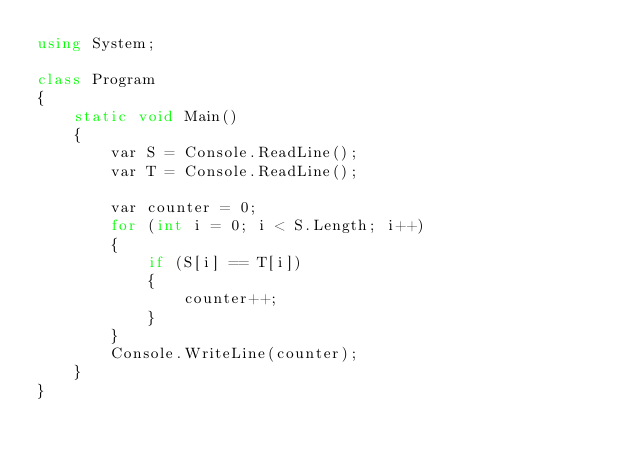<code> <loc_0><loc_0><loc_500><loc_500><_C#_>using System;

class Program
{
    static void Main()
    {
        var S = Console.ReadLine();
        var T = Console.ReadLine();

        var counter = 0;
        for (int i = 0; i < S.Length; i++)
        {
            if (S[i] == T[i])
            {
                counter++;
            }
        }
        Console.WriteLine(counter);
    }
}
</code> 